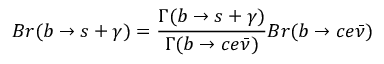Convert formula to latex. <formula><loc_0><loc_0><loc_500><loc_500>B r ( b \rightarrow s + \gamma ) = \frac { \Gamma ( b \rightarrow s + \gamma ) } { \Gamma ( b \rightarrow c e \bar { \nu } ) } B r ( b \rightarrow c e \bar { \nu } )</formula> 